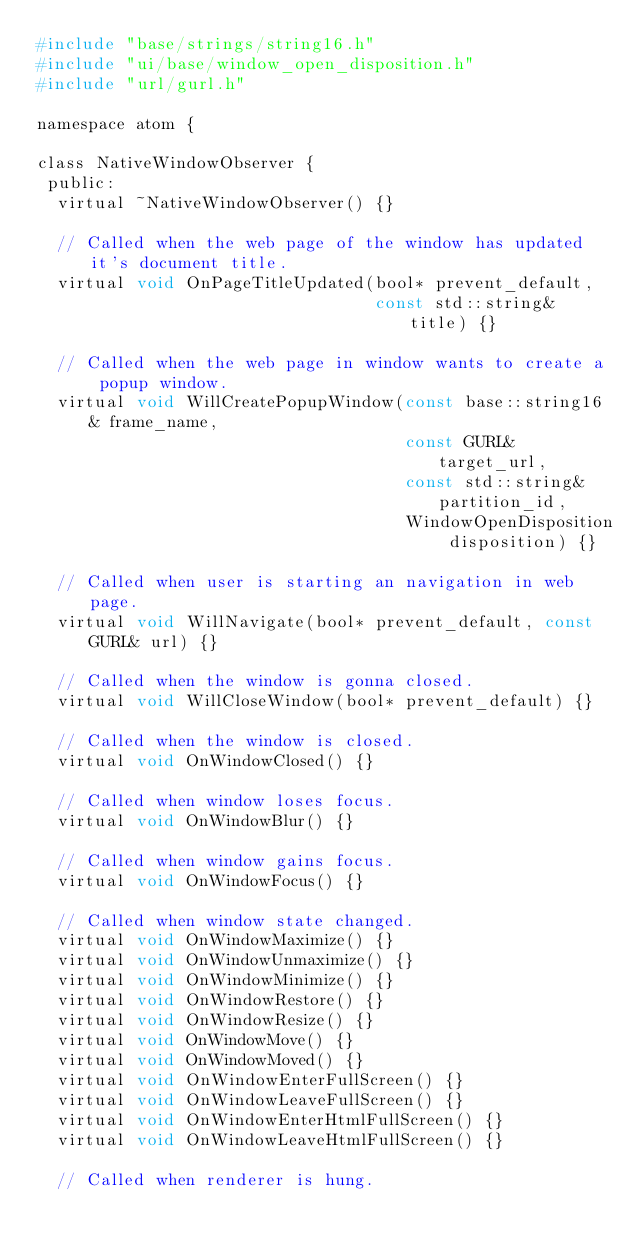<code> <loc_0><loc_0><loc_500><loc_500><_C_>#include "base/strings/string16.h"
#include "ui/base/window_open_disposition.h"
#include "url/gurl.h"

namespace atom {

class NativeWindowObserver {
 public:
  virtual ~NativeWindowObserver() {}

  // Called when the web page of the window has updated it's document title.
  virtual void OnPageTitleUpdated(bool* prevent_default,
                                  const std::string& title) {}

  // Called when the web page in window wants to create a popup window.
  virtual void WillCreatePopupWindow(const base::string16& frame_name,
                                     const GURL& target_url,
                                     const std::string& partition_id,
                                     WindowOpenDisposition disposition) {}

  // Called when user is starting an navigation in web page.
  virtual void WillNavigate(bool* prevent_default, const GURL& url) {}

  // Called when the window is gonna closed.
  virtual void WillCloseWindow(bool* prevent_default) {}

  // Called when the window is closed.
  virtual void OnWindowClosed() {}

  // Called when window loses focus.
  virtual void OnWindowBlur() {}

  // Called when window gains focus.
  virtual void OnWindowFocus() {}

  // Called when window state changed.
  virtual void OnWindowMaximize() {}
  virtual void OnWindowUnmaximize() {}
  virtual void OnWindowMinimize() {}
  virtual void OnWindowRestore() {}
  virtual void OnWindowResize() {}
  virtual void OnWindowMove() {}
  virtual void OnWindowMoved() {}
  virtual void OnWindowEnterFullScreen() {}
  virtual void OnWindowLeaveFullScreen() {}
  virtual void OnWindowEnterHtmlFullScreen() {}
  virtual void OnWindowLeaveHtmlFullScreen() {}

  // Called when renderer is hung.</code> 